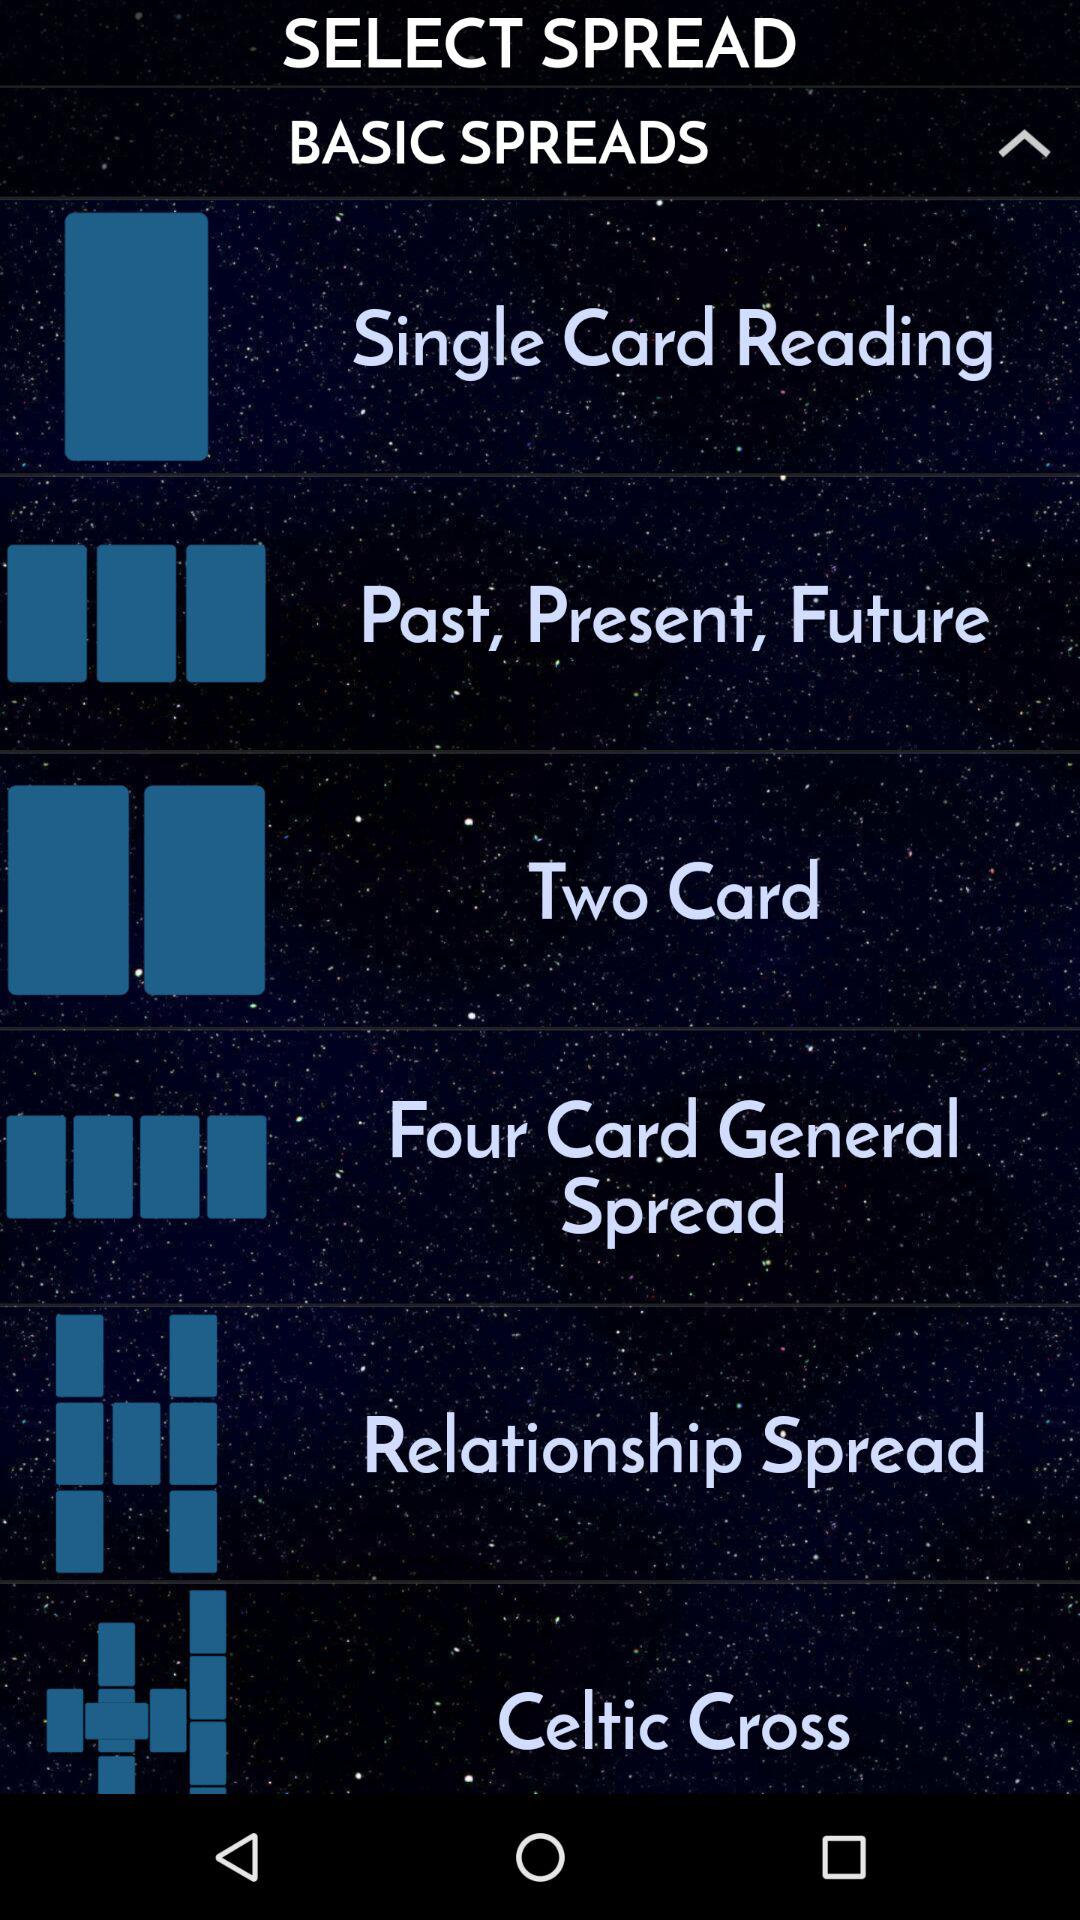How many more lines are on the Past, Present, Future spread than the Two Card spread?
Answer the question using a single word or phrase. 1 